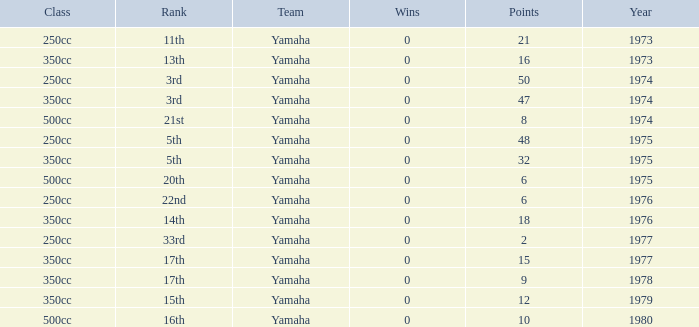Which Points is the lowest one that has a Year larger than 1974, and a Rank of 15th? 12.0. 